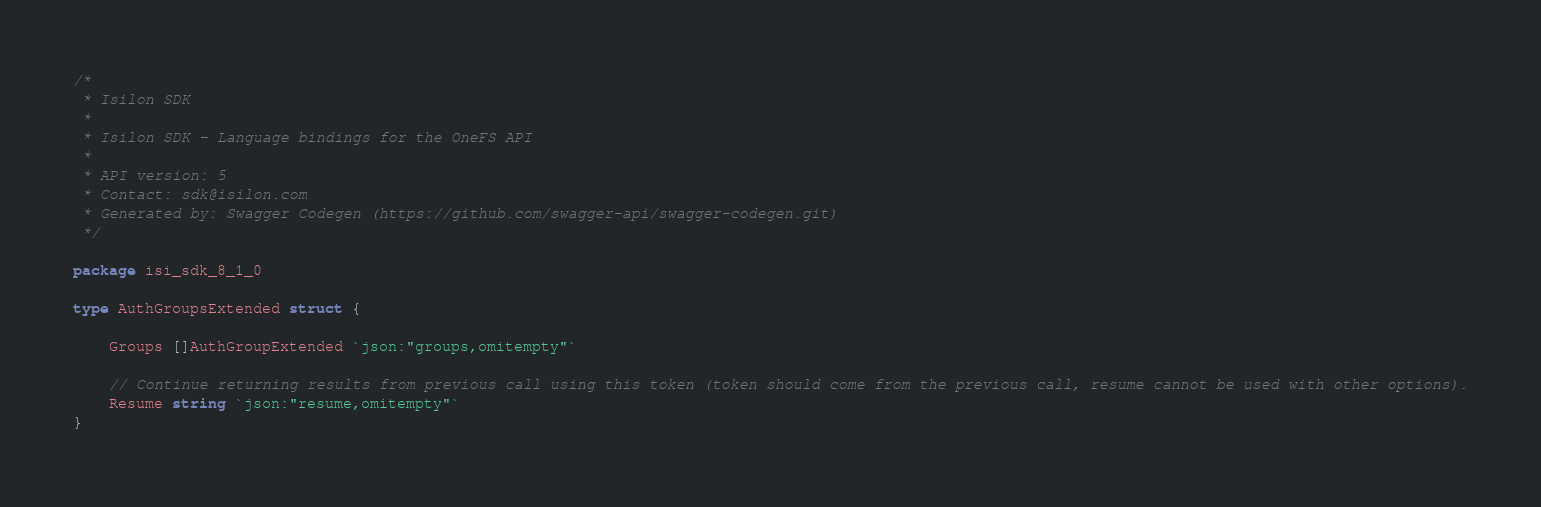Convert code to text. <code><loc_0><loc_0><loc_500><loc_500><_Go_>/*
 * Isilon SDK
 *
 * Isilon SDK - Language bindings for the OneFS API
 *
 * API version: 5
 * Contact: sdk@isilon.com
 * Generated by: Swagger Codegen (https://github.com/swagger-api/swagger-codegen.git)
 */

package isi_sdk_8_1_0

type AuthGroupsExtended struct {

	Groups []AuthGroupExtended `json:"groups,omitempty"`

	// Continue returning results from previous call using this token (token should come from the previous call, resume cannot be used with other options).
	Resume string `json:"resume,omitempty"`
}
</code> 